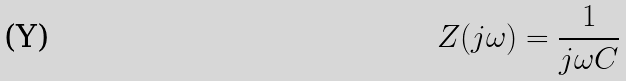Convert formula to latex. <formula><loc_0><loc_0><loc_500><loc_500>Z ( j \omega ) = { \frac { 1 } { j \omega C } }</formula> 